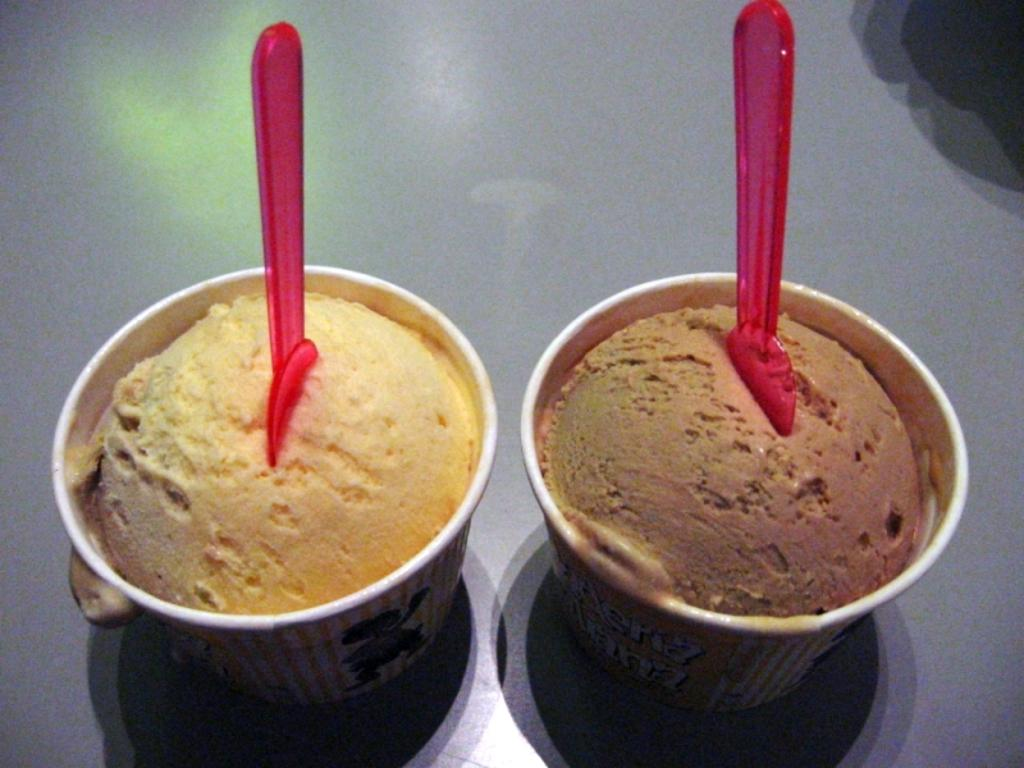What is the main piece of furniture in the image? There is a table in the image. What is on the table? There are two cups of ice cream on the table. What utensils are present on the table? There are spoons on the table. What type of toothpaste is being used to flavor the ice cream in the image? There is no toothpaste present in the image, and toothpaste is not used to flavor ice cream. 